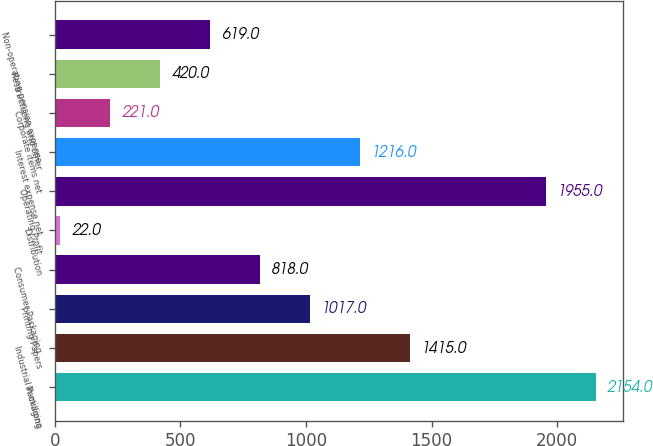Convert chart. <chart><loc_0><loc_0><loc_500><loc_500><bar_chart><fcel>In millions<fcel>Industrial Packaging<fcel>Printing Papers<fcel>Consumer Packaging<fcel>Distribution<fcel>Operating Profit<fcel>Interest expense net<fcel>Corporate items net<fcel>Restructuring and other<fcel>Non-operating pension expense<nl><fcel>2154<fcel>1415<fcel>1017<fcel>818<fcel>22<fcel>1955<fcel>1216<fcel>221<fcel>420<fcel>619<nl></chart> 